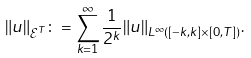<formula> <loc_0><loc_0><loc_500><loc_500>\| u \| _ { \mathcal { E } ^ { T } } \colon = \sum _ { k = 1 } ^ { \infty } \frac { 1 } { 2 ^ { k } } \| u \| _ { L ^ { \infty } ( [ - k , k ] \times [ 0 , T ] ) } .</formula> 